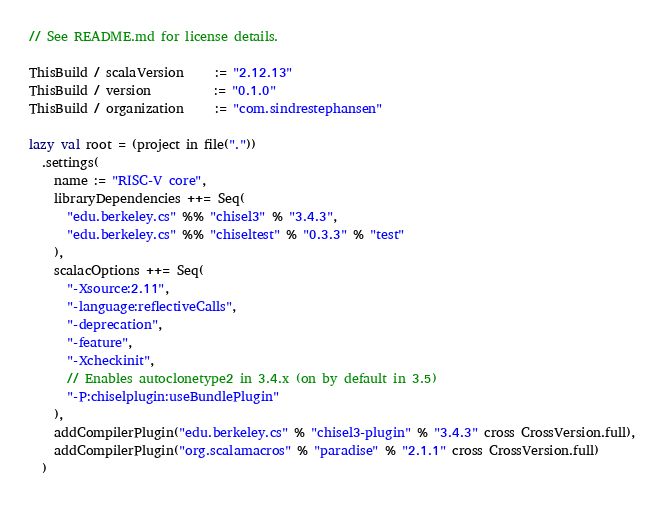Convert code to text. <code><loc_0><loc_0><loc_500><loc_500><_Scala_>// See README.md for license details.

ThisBuild / scalaVersion     := "2.12.13"
ThisBuild / version          := "0.1.0"
ThisBuild / organization     := "com.sindrestephansen"

lazy val root = (project in file("."))
  .settings(
    name := "RISC-V core",
    libraryDependencies ++= Seq(
      "edu.berkeley.cs" %% "chisel3" % "3.4.3",
      "edu.berkeley.cs" %% "chiseltest" % "0.3.3" % "test"
    ),
    scalacOptions ++= Seq(
      "-Xsource:2.11",
      "-language:reflectiveCalls",
      "-deprecation",
      "-feature",
      "-Xcheckinit",
      // Enables autoclonetype2 in 3.4.x (on by default in 3.5)
      "-P:chiselplugin:useBundlePlugin"
    ),
    addCompilerPlugin("edu.berkeley.cs" % "chisel3-plugin" % "3.4.3" cross CrossVersion.full),
    addCompilerPlugin("org.scalamacros" % "paradise" % "2.1.1" cross CrossVersion.full)
  )
</code> 